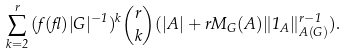Convert formula to latex. <formula><loc_0><loc_0><loc_500><loc_500>\sum _ { k = 2 } ^ { r } { ( f ( \gamma ) | G | ^ { - 1 } ) ^ { k } \binom { r } { k } } ( | A | + r M _ { G } ( A ) \| 1 _ { A } \| _ { A ( G ) } ^ { r - 1 } ) .</formula> 